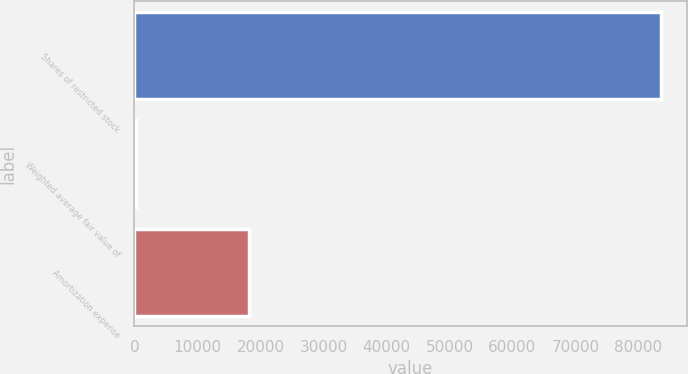Convert chart to OTSL. <chart><loc_0><loc_0><loc_500><loc_500><bar_chart><fcel>Shares of restricted stock<fcel>Weighted average fair value of<fcel>Amortization expense<nl><fcel>83509<fcel>166.36<fcel>18256<nl></chart> 